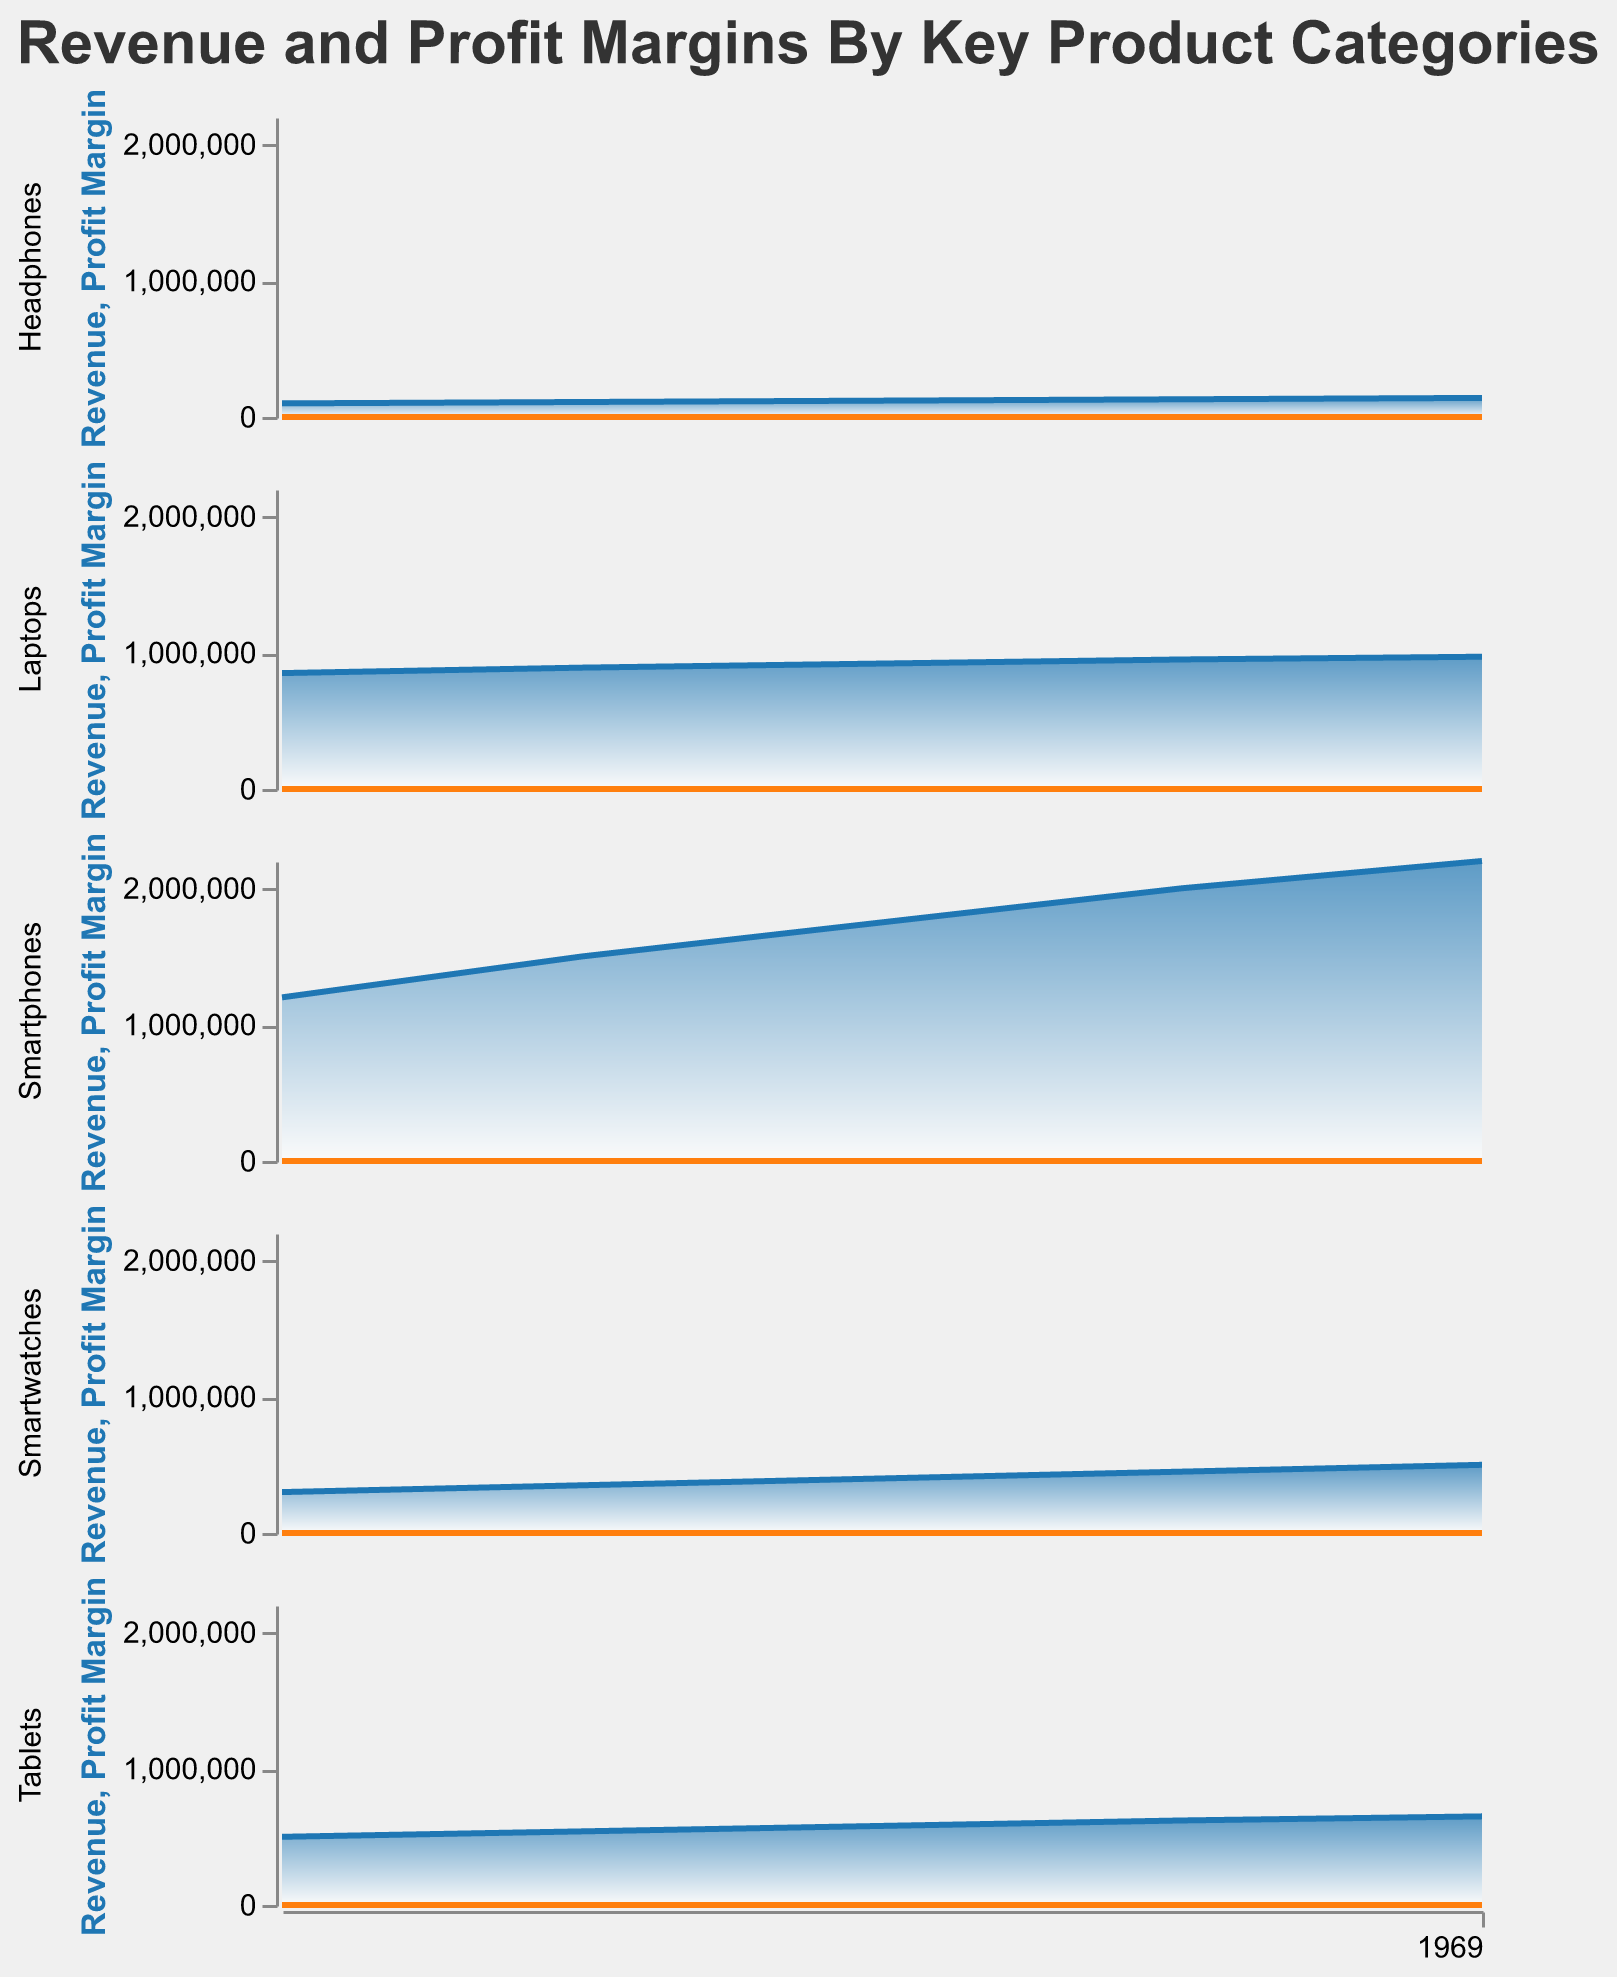What's the total revenue for Smartwatches across the five years? The revenues for Smartwatches from 2018 to 2022 are 300000, 350000, 400000, 450000, and 500000 respectively. Adding these values gives 300000 + 350000 + 400000 + 450000 + 500000 = 2,000,000.
Answer: 2000000 Which year shows the highest profit margin for Tablets? The profit margins for Tablets from 2018 to 2022 are 0.12, 0.13, 0.15, 0.16, and 0.18 respectively. The highest value among these is 0.18 in 2022.
Answer: 2022 How does the revenue trend for Smartphones compare to the revenue trend for Laptops over the reported years? The revenue for Smartphones increased steadily from 1200000 in 2018 to 2200000 in 2022. The revenue for Laptops shows a smaller increase, from 850000 in 2018 to 970000 in 2022.
Answer: Smartphones increased more significantly than Laptops What is the average profit margin for Headphones over the five years? The profit margins for Headphones from 2018 to 2022 are 0.18, 0.2, 0.22, 0.24, and 0.25. Their sum is 0.18 + 0.2 + 0.22 + 0.24 + 0.25 = 1.09. The average is 1.09 divided by 5, which gives 1.09/5 = 0.218.
Answer: 0.218 Between Smartwatches and Tablets, which category had a higher increase in revenue from 2018 to 2022? The revenue for Smartwatches in 2018 and 2022 are 300000 and 500000, respectively, giving an increase of 500000 - 300000 = 200000. For Tablets, the revenue in 2018 and 2022 are 500000 and 650000, respectively, giving an increase of 650000 - 500000 = 150000. Smartwatches had a higher increase of 200000 compared to Tablets' 150000.
Answer: Smartwatches Which product category had the highest profit margin in 2020? In 2020, the profit margins for the categories are as follows: Smartphones (0.25), Laptops (0.19), Tablets (0.15), Smartwatches (0.26), Headphones (0.22). The highest profit margin is 0.26 for Smartwatches.
Answer: Smartwatches What is the overall trend in profit margins for Laptops from 2018 to 2022? The profit margins for Laptops are 0.15, 0.17, 0.19, 0.21, and 0.22 from 2018 to 2022 respectively. The trend shows a consistent increase each year.
Answer: Increasing Do Smartwatches and Headphones have similar revenue trends? From the data, Smartwatches' revenue increased steadily from 300000 in 2018 to 500000 in 2022, while Headphones' revenue increased more moderately from 100000 in 2018 to 140000 in 2022. Both show an increasing trend, but the increase for Smartwatches is more significant.
Answer: No 